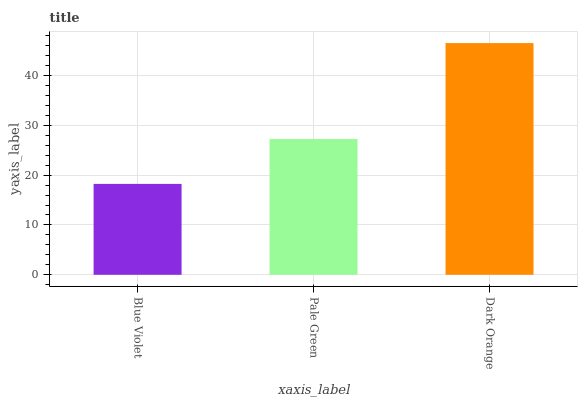Is Blue Violet the minimum?
Answer yes or no. Yes. Is Dark Orange the maximum?
Answer yes or no. Yes. Is Pale Green the minimum?
Answer yes or no. No. Is Pale Green the maximum?
Answer yes or no. No. Is Pale Green greater than Blue Violet?
Answer yes or no. Yes. Is Blue Violet less than Pale Green?
Answer yes or no. Yes. Is Blue Violet greater than Pale Green?
Answer yes or no. No. Is Pale Green less than Blue Violet?
Answer yes or no. No. Is Pale Green the high median?
Answer yes or no. Yes. Is Pale Green the low median?
Answer yes or no. Yes. Is Blue Violet the high median?
Answer yes or no. No. Is Dark Orange the low median?
Answer yes or no. No. 